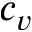<formula> <loc_0><loc_0><loc_500><loc_500>c _ { v }</formula> 